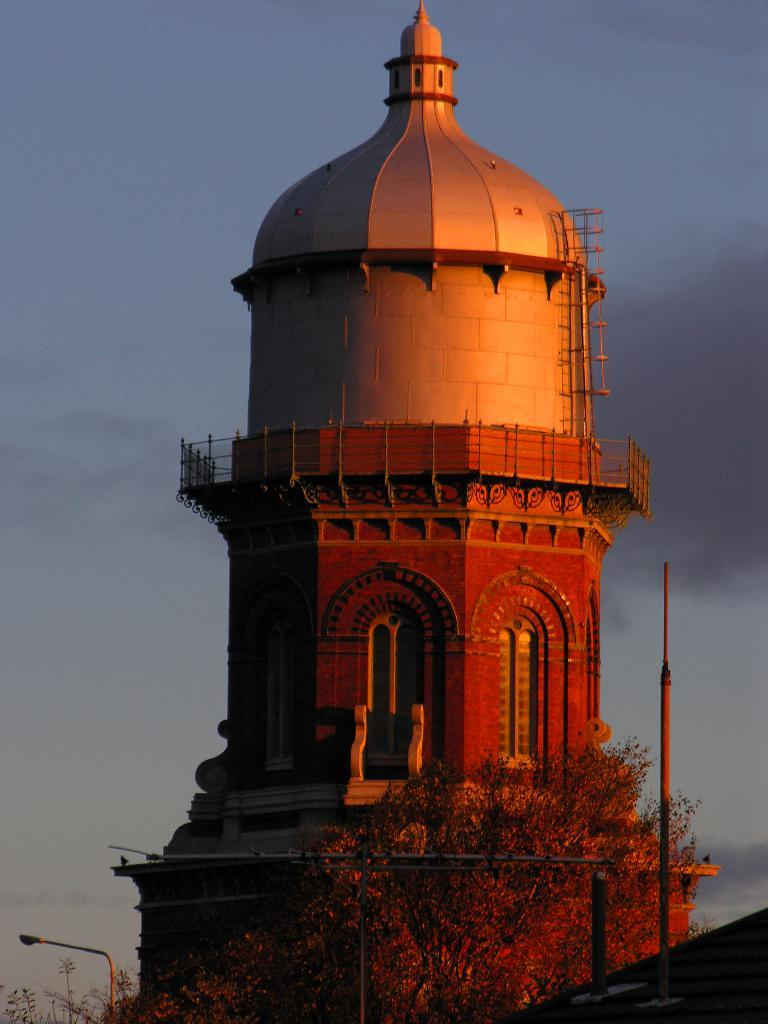What type of structure is present in the image? There is a construction that resembles a minar in the image. What other object can be seen at the bottom of the image? There is a tree at the bottom of the image. What is visible in the background of the image? The sky is visible in the background of the image. How many carts are being pushed by the babies in the image? There are no carts or babies present in the image. What type of songs can be heard coming from the minar in the image? There is no indication of any sounds, including songs, in the image. 